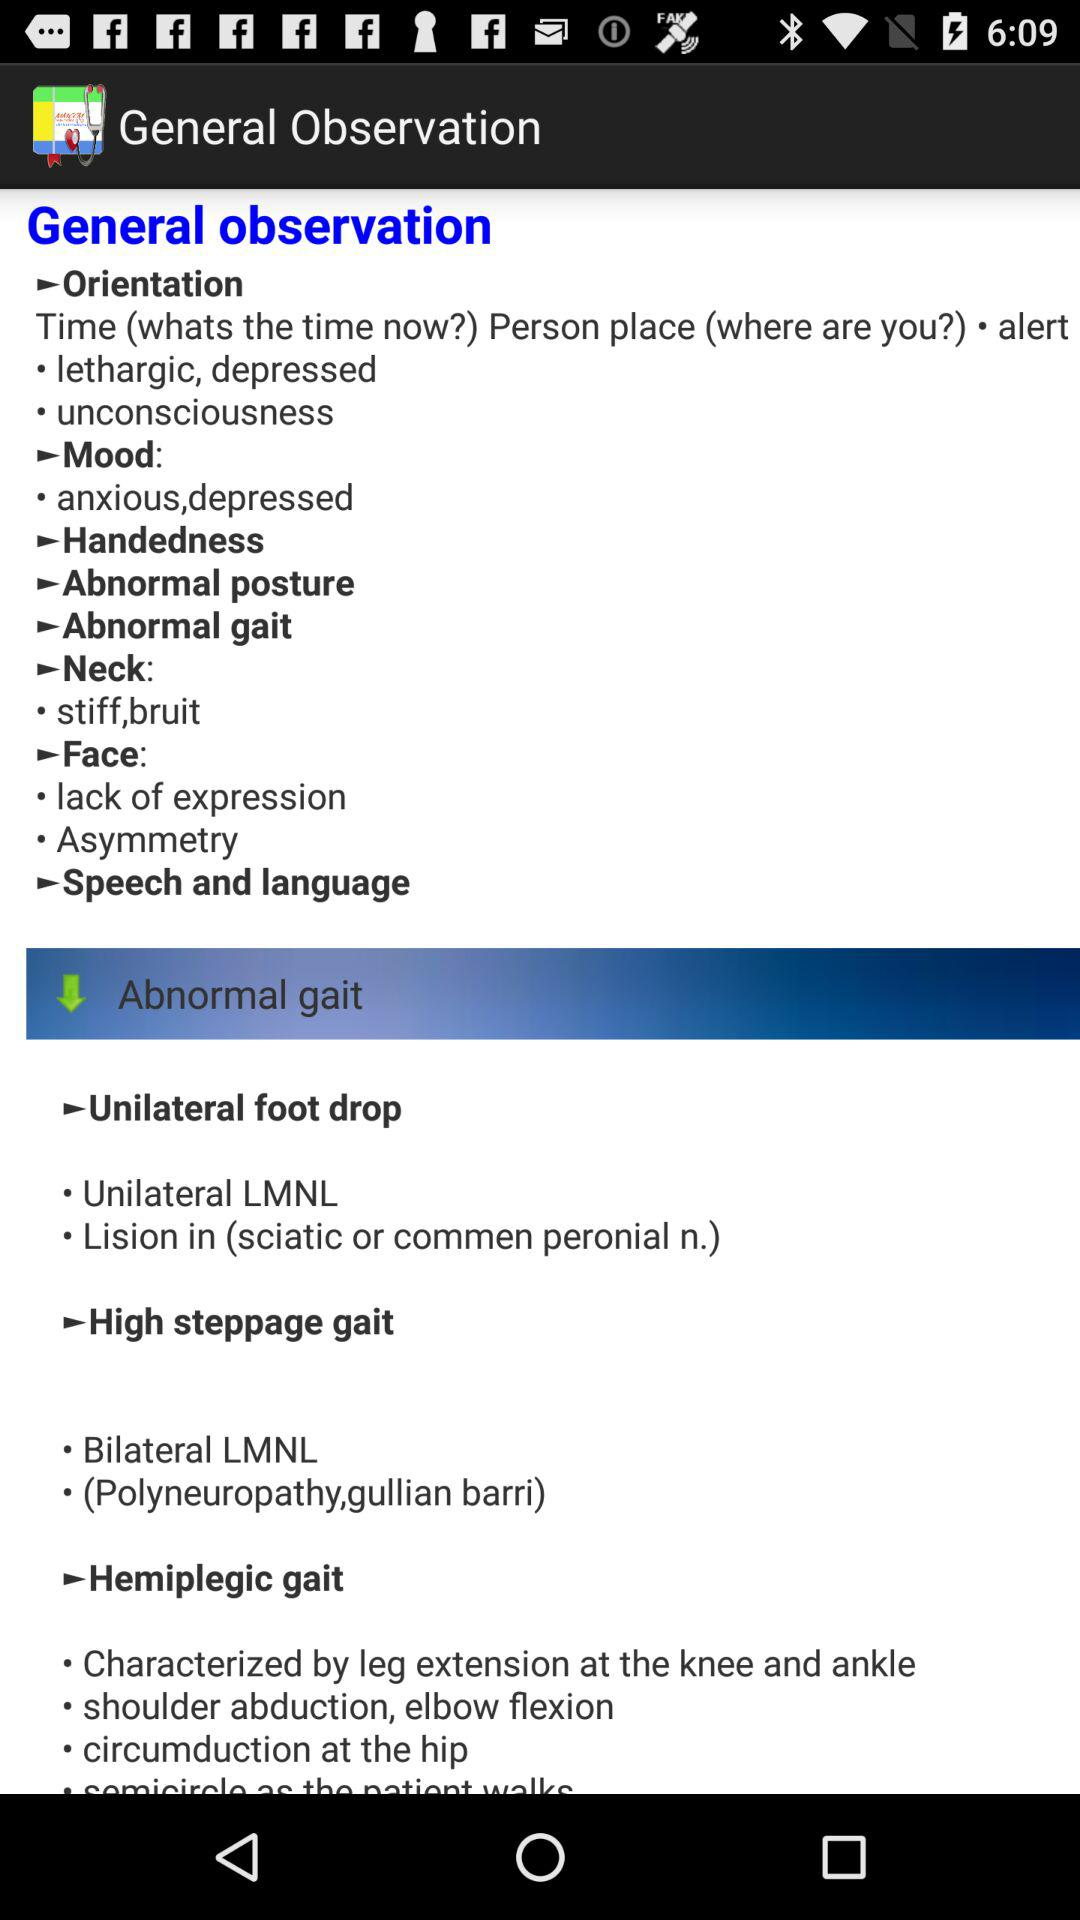What is the general observation of "Face"? The general observations are "lack of expression" and "Asymmetry". 